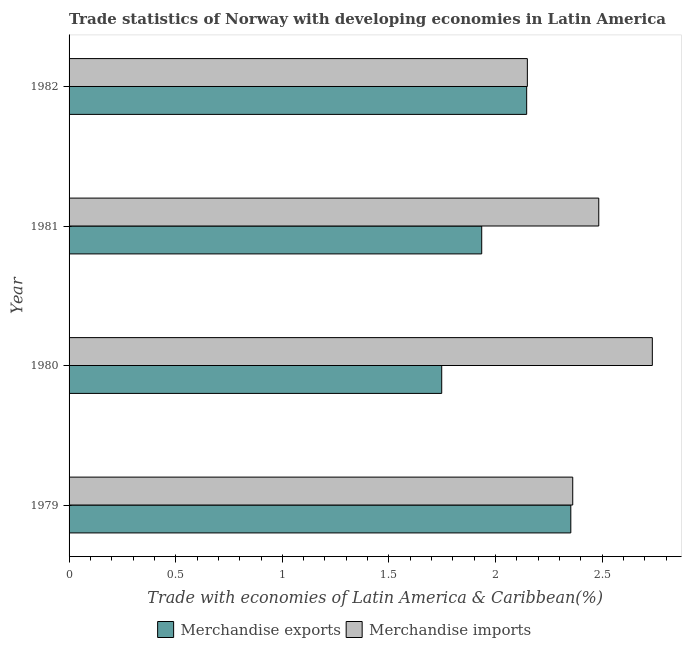How many groups of bars are there?
Your response must be concise. 4. Are the number of bars per tick equal to the number of legend labels?
Offer a very short reply. Yes. How many bars are there on the 3rd tick from the top?
Ensure brevity in your answer.  2. How many bars are there on the 1st tick from the bottom?
Ensure brevity in your answer.  2. What is the label of the 2nd group of bars from the top?
Your response must be concise. 1981. What is the merchandise exports in 1979?
Offer a terse response. 2.35. Across all years, what is the maximum merchandise imports?
Keep it short and to the point. 2.73. Across all years, what is the minimum merchandise imports?
Keep it short and to the point. 2.15. In which year was the merchandise exports maximum?
Offer a very short reply. 1979. What is the total merchandise exports in the graph?
Your response must be concise. 8.18. What is the difference between the merchandise exports in 1980 and that in 1981?
Your answer should be compact. -0.19. What is the difference between the merchandise imports in 1981 and the merchandise exports in 1980?
Keep it short and to the point. 0.74. What is the average merchandise imports per year?
Provide a succinct answer. 2.43. In the year 1979, what is the difference between the merchandise exports and merchandise imports?
Give a very brief answer. -0.01. What is the ratio of the merchandise exports in 1979 to that in 1980?
Your answer should be compact. 1.35. Is the difference between the merchandise imports in 1980 and 1981 greater than the difference between the merchandise exports in 1980 and 1981?
Your answer should be compact. Yes. What is the difference between the highest and the second highest merchandise exports?
Keep it short and to the point. 0.21. What is the difference between the highest and the lowest merchandise imports?
Your response must be concise. 0.59. Is the sum of the merchandise imports in 1979 and 1981 greater than the maximum merchandise exports across all years?
Give a very brief answer. Yes. What does the 2nd bar from the top in 1979 represents?
Ensure brevity in your answer.  Merchandise exports. What does the 2nd bar from the bottom in 1980 represents?
Offer a terse response. Merchandise imports. How many legend labels are there?
Provide a succinct answer. 2. What is the title of the graph?
Your answer should be very brief. Trade statistics of Norway with developing economies in Latin America. What is the label or title of the X-axis?
Your response must be concise. Trade with economies of Latin America & Caribbean(%). What is the Trade with economies of Latin America & Caribbean(%) in Merchandise exports in 1979?
Your answer should be very brief. 2.35. What is the Trade with economies of Latin America & Caribbean(%) in Merchandise imports in 1979?
Your answer should be compact. 2.36. What is the Trade with economies of Latin America & Caribbean(%) in Merchandise exports in 1980?
Provide a succinct answer. 1.75. What is the Trade with economies of Latin America & Caribbean(%) in Merchandise imports in 1980?
Give a very brief answer. 2.73. What is the Trade with economies of Latin America & Caribbean(%) in Merchandise exports in 1981?
Offer a very short reply. 1.93. What is the Trade with economies of Latin America & Caribbean(%) in Merchandise imports in 1981?
Offer a very short reply. 2.48. What is the Trade with economies of Latin America & Caribbean(%) of Merchandise exports in 1982?
Offer a terse response. 2.15. What is the Trade with economies of Latin America & Caribbean(%) of Merchandise imports in 1982?
Keep it short and to the point. 2.15. Across all years, what is the maximum Trade with economies of Latin America & Caribbean(%) in Merchandise exports?
Offer a very short reply. 2.35. Across all years, what is the maximum Trade with economies of Latin America & Caribbean(%) in Merchandise imports?
Ensure brevity in your answer.  2.73. Across all years, what is the minimum Trade with economies of Latin America & Caribbean(%) of Merchandise exports?
Keep it short and to the point. 1.75. Across all years, what is the minimum Trade with economies of Latin America & Caribbean(%) of Merchandise imports?
Your answer should be very brief. 2.15. What is the total Trade with economies of Latin America & Caribbean(%) in Merchandise exports in the graph?
Provide a short and direct response. 8.18. What is the total Trade with economies of Latin America & Caribbean(%) of Merchandise imports in the graph?
Give a very brief answer. 9.73. What is the difference between the Trade with economies of Latin America & Caribbean(%) in Merchandise exports in 1979 and that in 1980?
Your answer should be compact. 0.61. What is the difference between the Trade with economies of Latin America & Caribbean(%) of Merchandise imports in 1979 and that in 1980?
Ensure brevity in your answer.  -0.37. What is the difference between the Trade with economies of Latin America & Caribbean(%) of Merchandise exports in 1979 and that in 1981?
Offer a terse response. 0.42. What is the difference between the Trade with economies of Latin America & Caribbean(%) of Merchandise imports in 1979 and that in 1981?
Provide a short and direct response. -0.12. What is the difference between the Trade with economies of Latin America & Caribbean(%) of Merchandise exports in 1979 and that in 1982?
Provide a succinct answer. 0.21. What is the difference between the Trade with economies of Latin America & Caribbean(%) of Merchandise imports in 1979 and that in 1982?
Provide a succinct answer. 0.21. What is the difference between the Trade with economies of Latin America & Caribbean(%) in Merchandise exports in 1980 and that in 1981?
Keep it short and to the point. -0.19. What is the difference between the Trade with economies of Latin America & Caribbean(%) of Merchandise imports in 1980 and that in 1981?
Your answer should be compact. 0.25. What is the difference between the Trade with economies of Latin America & Caribbean(%) of Merchandise exports in 1980 and that in 1982?
Offer a very short reply. -0.4. What is the difference between the Trade with economies of Latin America & Caribbean(%) of Merchandise imports in 1980 and that in 1982?
Give a very brief answer. 0.59. What is the difference between the Trade with economies of Latin America & Caribbean(%) of Merchandise exports in 1981 and that in 1982?
Offer a very short reply. -0.21. What is the difference between the Trade with economies of Latin America & Caribbean(%) in Merchandise imports in 1981 and that in 1982?
Provide a succinct answer. 0.33. What is the difference between the Trade with economies of Latin America & Caribbean(%) in Merchandise exports in 1979 and the Trade with economies of Latin America & Caribbean(%) in Merchandise imports in 1980?
Give a very brief answer. -0.38. What is the difference between the Trade with economies of Latin America & Caribbean(%) in Merchandise exports in 1979 and the Trade with economies of Latin America & Caribbean(%) in Merchandise imports in 1981?
Provide a short and direct response. -0.13. What is the difference between the Trade with economies of Latin America & Caribbean(%) of Merchandise exports in 1979 and the Trade with economies of Latin America & Caribbean(%) of Merchandise imports in 1982?
Offer a very short reply. 0.2. What is the difference between the Trade with economies of Latin America & Caribbean(%) in Merchandise exports in 1980 and the Trade with economies of Latin America & Caribbean(%) in Merchandise imports in 1981?
Keep it short and to the point. -0.74. What is the difference between the Trade with economies of Latin America & Caribbean(%) of Merchandise exports in 1980 and the Trade with economies of Latin America & Caribbean(%) of Merchandise imports in 1982?
Offer a very short reply. -0.4. What is the difference between the Trade with economies of Latin America & Caribbean(%) of Merchandise exports in 1981 and the Trade with economies of Latin America & Caribbean(%) of Merchandise imports in 1982?
Provide a succinct answer. -0.21. What is the average Trade with economies of Latin America & Caribbean(%) of Merchandise exports per year?
Offer a terse response. 2.05. What is the average Trade with economies of Latin America & Caribbean(%) of Merchandise imports per year?
Offer a very short reply. 2.43. In the year 1979, what is the difference between the Trade with economies of Latin America & Caribbean(%) of Merchandise exports and Trade with economies of Latin America & Caribbean(%) of Merchandise imports?
Your answer should be very brief. -0.01. In the year 1980, what is the difference between the Trade with economies of Latin America & Caribbean(%) of Merchandise exports and Trade with economies of Latin America & Caribbean(%) of Merchandise imports?
Ensure brevity in your answer.  -0.99. In the year 1981, what is the difference between the Trade with economies of Latin America & Caribbean(%) in Merchandise exports and Trade with economies of Latin America & Caribbean(%) in Merchandise imports?
Make the answer very short. -0.55. In the year 1982, what is the difference between the Trade with economies of Latin America & Caribbean(%) in Merchandise exports and Trade with economies of Latin America & Caribbean(%) in Merchandise imports?
Keep it short and to the point. -0. What is the ratio of the Trade with economies of Latin America & Caribbean(%) of Merchandise exports in 1979 to that in 1980?
Give a very brief answer. 1.35. What is the ratio of the Trade with economies of Latin America & Caribbean(%) in Merchandise imports in 1979 to that in 1980?
Ensure brevity in your answer.  0.86. What is the ratio of the Trade with economies of Latin America & Caribbean(%) of Merchandise exports in 1979 to that in 1981?
Your response must be concise. 1.22. What is the ratio of the Trade with economies of Latin America & Caribbean(%) of Merchandise imports in 1979 to that in 1981?
Your answer should be compact. 0.95. What is the ratio of the Trade with economies of Latin America & Caribbean(%) in Merchandise exports in 1979 to that in 1982?
Keep it short and to the point. 1.1. What is the ratio of the Trade with economies of Latin America & Caribbean(%) in Merchandise imports in 1979 to that in 1982?
Offer a terse response. 1.1. What is the ratio of the Trade with economies of Latin America & Caribbean(%) in Merchandise exports in 1980 to that in 1981?
Give a very brief answer. 0.9. What is the ratio of the Trade with economies of Latin America & Caribbean(%) of Merchandise imports in 1980 to that in 1981?
Keep it short and to the point. 1.1. What is the ratio of the Trade with economies of Latin America & Caribbean(%) of Merchandise exports in 1980 to that in 1982?
Give a very brief answer. 0.81. What is the ratio of the Trade with economies of Latin America & Caribbean(%) of Merchandise imports in 1980 to that in 1982?
Keep it short and to the point. 1.27. What is the ratio of the Trade with economies of Latin America & Caribbean(%) in Merchandise exports in 1981 to that in 1982?
Ensure brevity in your answer.  0.9. What is the ratio of the Trade with economies of Latin America & Caribbean(%) of Merchandise imports in 1981 to that in 1982?
Your answer should be compact. 1.16. What is the difference between the highest and the second highest Trade with economies of Latin America & Caribbean(%) in Merchandise exports?
Give a very brief answer. 0.21. What is the difference between the highest and the second highest Trade with economies of Latin America & Caribbean(%) in Merchandise imports?
Provide a short and direct response. 0.25. What is the difference between the highest and the lowest Trade with economies of Latin America & Caribbean(%) of Merchandise exports?
Give a very brief answer. 0.61. What is the difference between the highest and the lowest Trade with economies of Latin America & Caribbean(%) in Merchandise imports?
Ensure brevity in your answer.  0.59. 